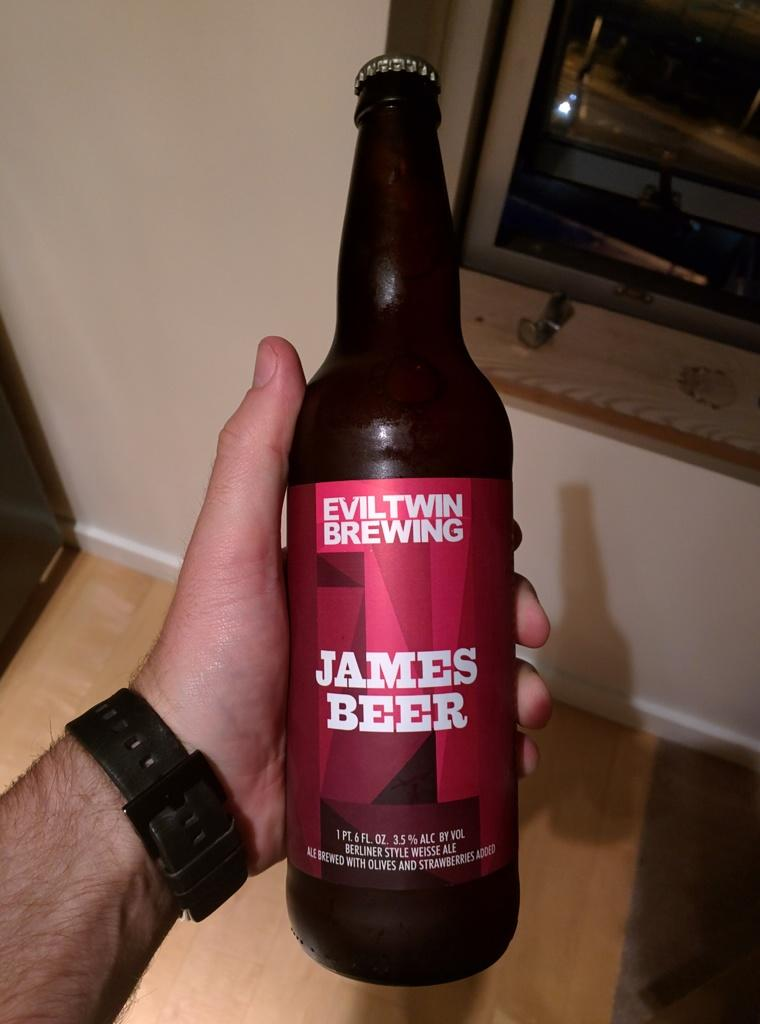<image>
Relay a brief, clear account of the picture shown. Man holding a bottle of "James Beer" by Eviltwin Brewing. 